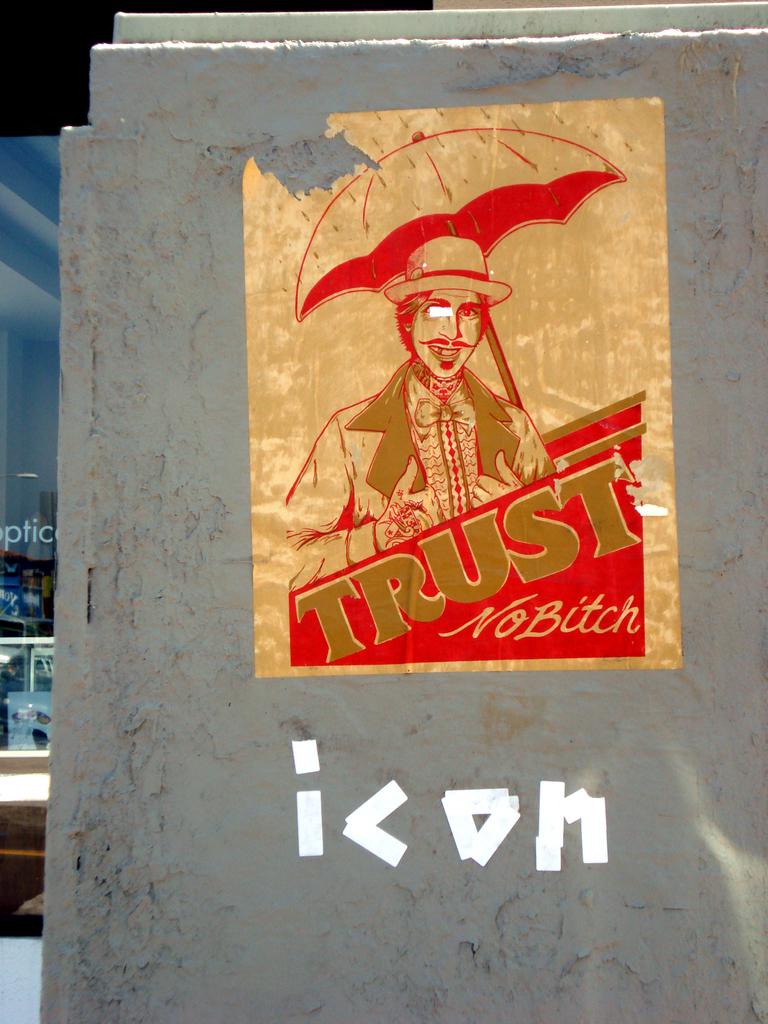What is to trust?
Offer a very short reply. No bitch. What word is in white?
Offer a terse response. Icon. 